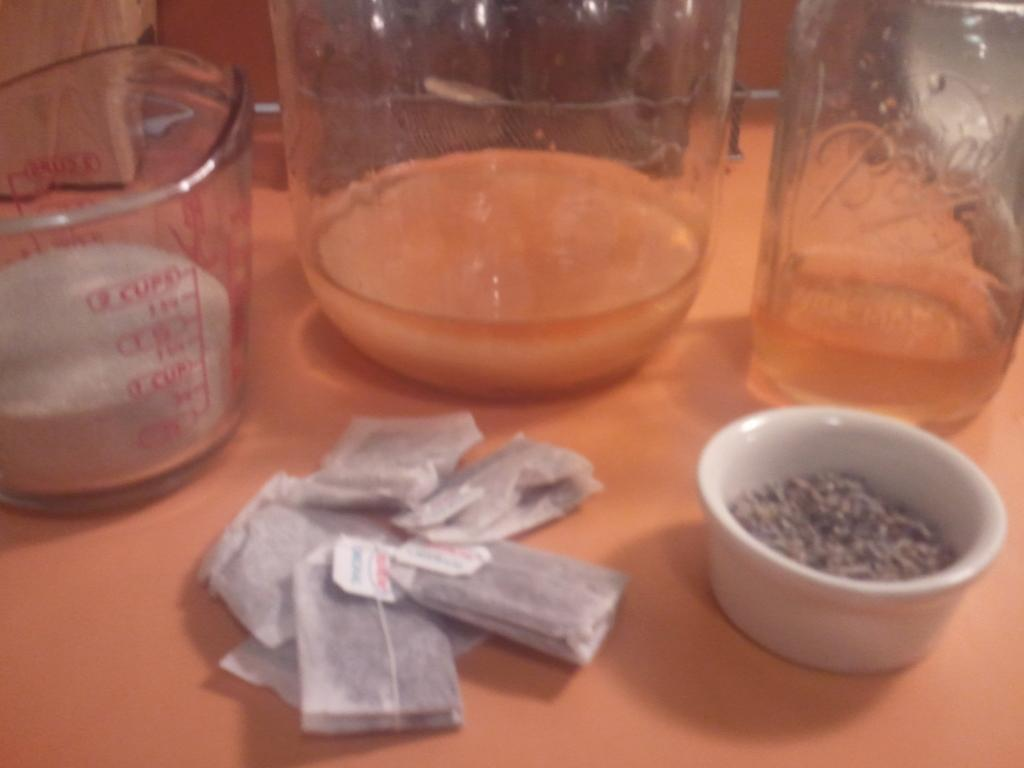<image>
Describe the image concisely. Nearly a full cup of an ingredient is in a measuring cup. 